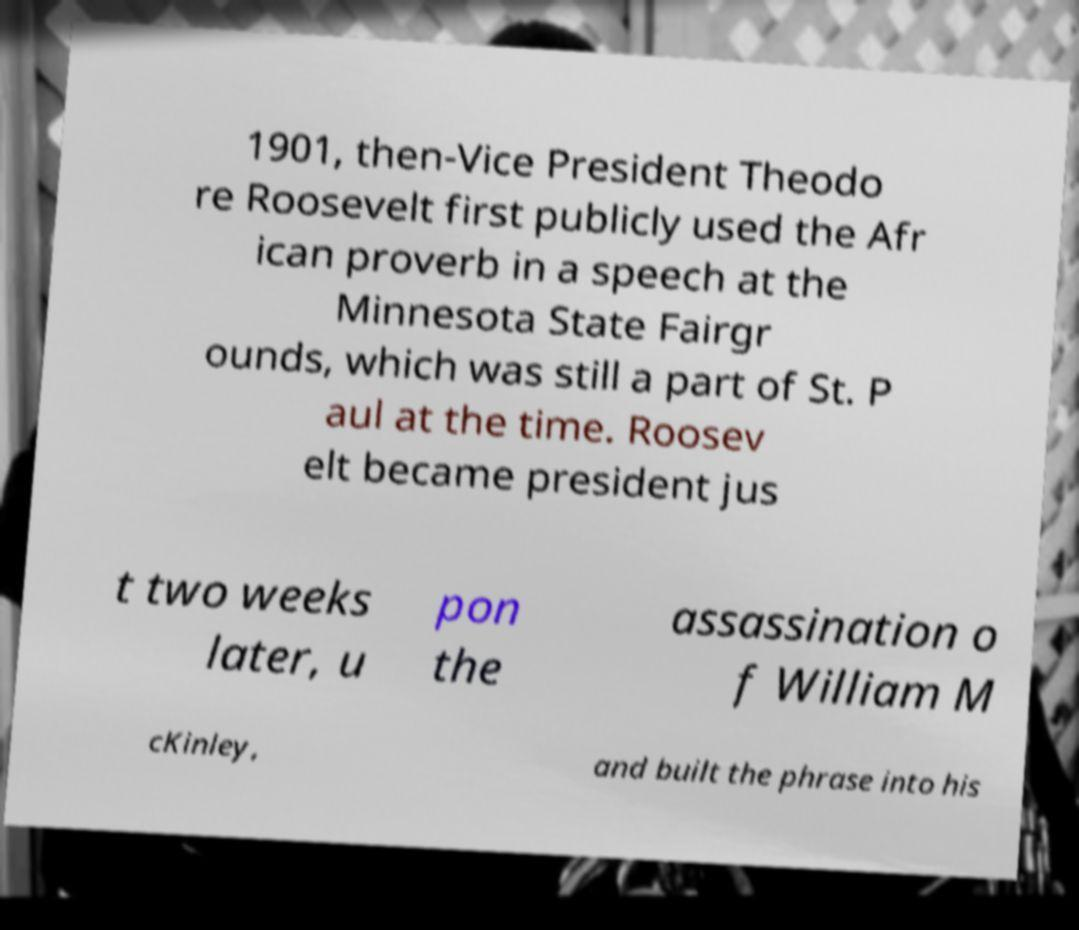For documentation purposes, I need the text within this image transcribed. Could you provide that? 1901, then-Vice President Theodo re Roosevelt first publicly used the Afr ican proverb in a speech at the Minnesota State Fairgr ounds, which was still a part of St. P aul at the time. Roosev elt became president jus t two weeks later, u pon the assassination o f William M cKinley, and built the phrase into his 